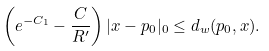Convert formula to latex. <formula><loc_0><loc_0><loc_500><loc_500>\left ( e ^ { - C _ { 1 } } - \frac { C } { R ^ { \prime } } \right ) | x - p _ { 0 } | _ { 0 } \leq d _ { w } ( p _ { 0 } , x ) .</formula> 